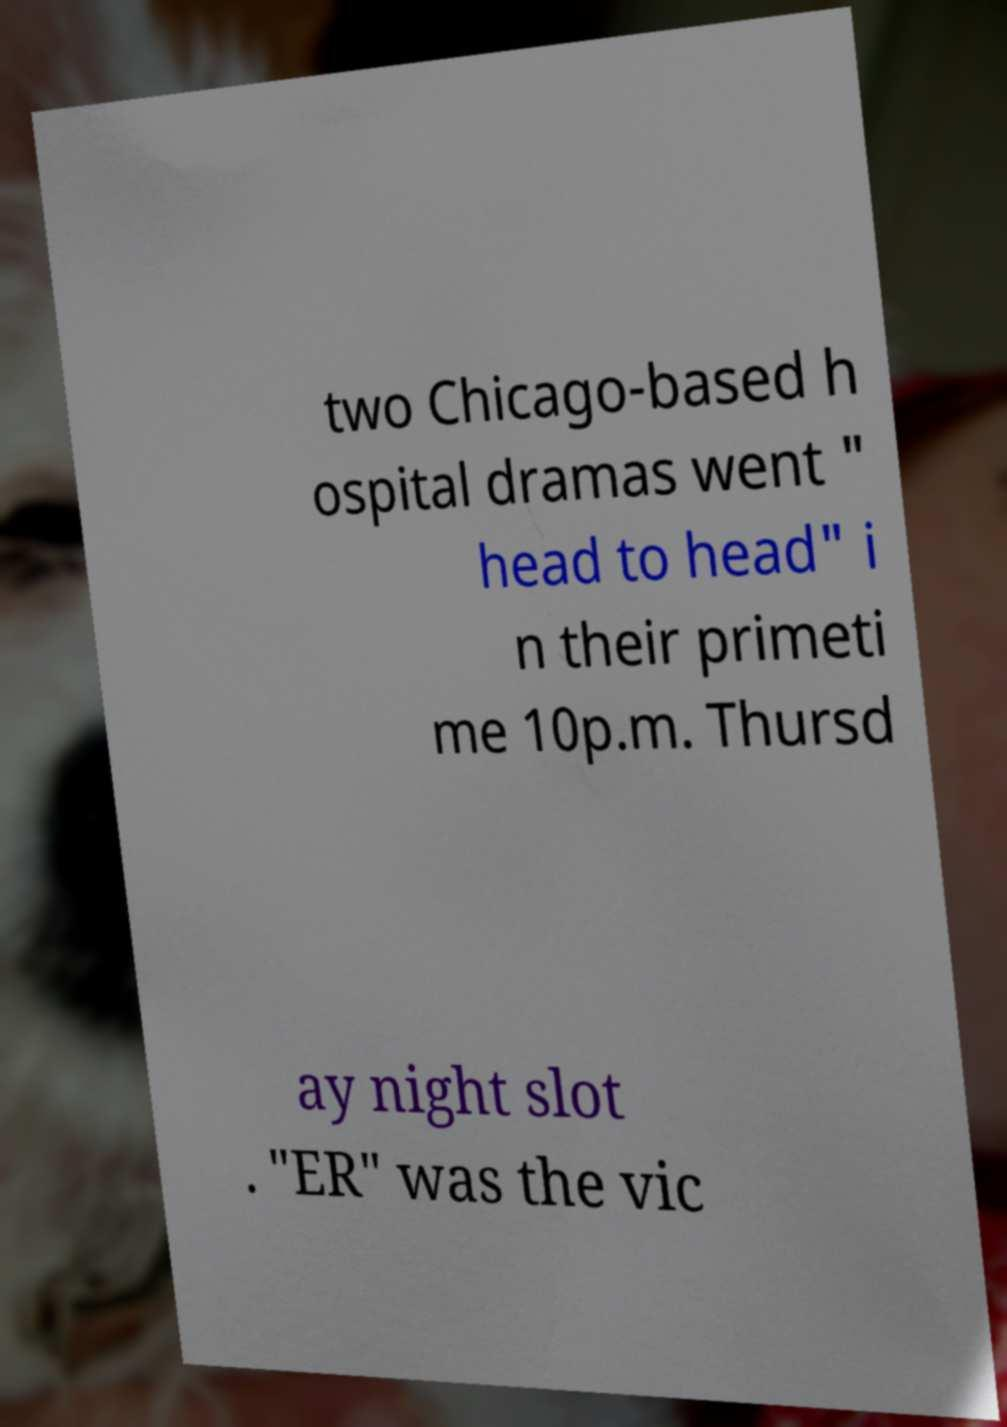Could you extract and type out the text from this image? two Chicago-based h ospital dramas went " head to head" i n their primeti me 10p.m. Thursd ay night slot . "ER" was the vic 